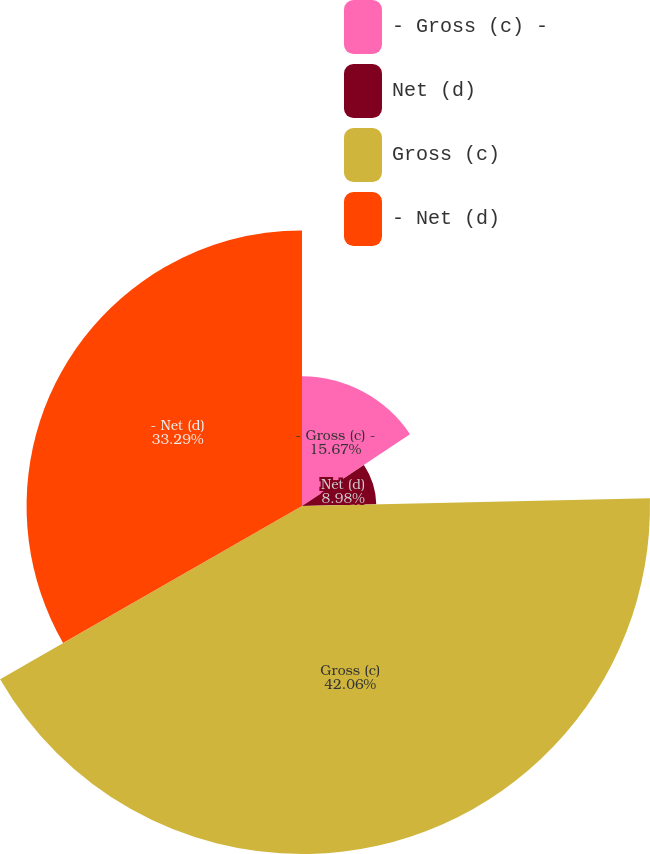Convert chart to OTSL. <chart><loc_0><loc_0><loc_500><loc_500><pie_chart><fcel>- Gross (c) -<fcel>Net (d)<fcel>Gross (c)<fcel>- Net (d)<nl><fcel>15.67%<fcel>8.98%<fcel>42.06%<fcel>33.29%<nl></chart> 